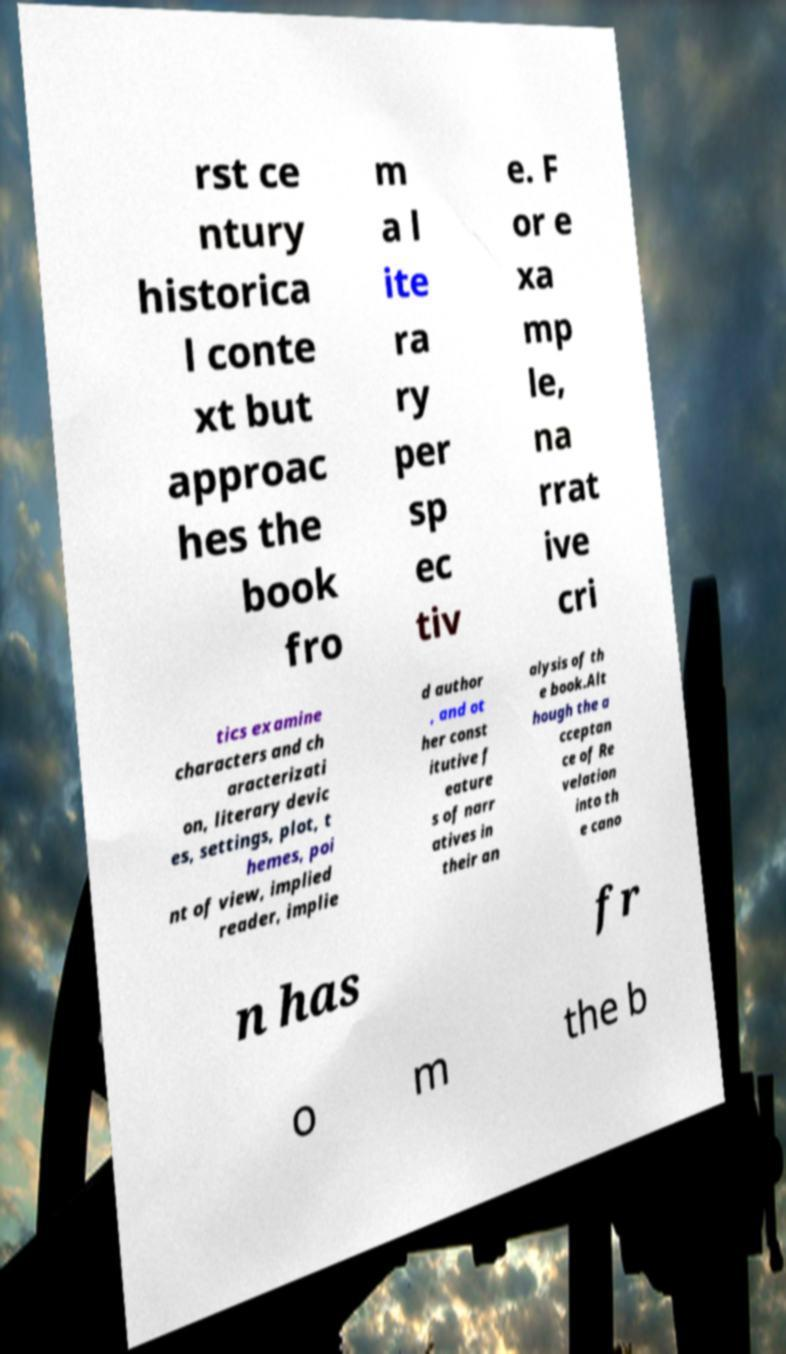There's text embedded in this image that I need extracted. Can you transcribe it verbatim? rst ce ntury historica l conte xt but approac hes the book fro m a l ite ra ry per sp ec tiv e. F or e xa mp le, na rrat ive cri tics examine characters and ch aracterizati on, literary devic es, settings, plot, t hemes, poi nt of view, implied reader, implie d author , and ot her const itutive f eature s of narr atives in their an alysis of th e book.Alt hough the a cceptan ce of Re velation into th e cano n has fr o m the b 